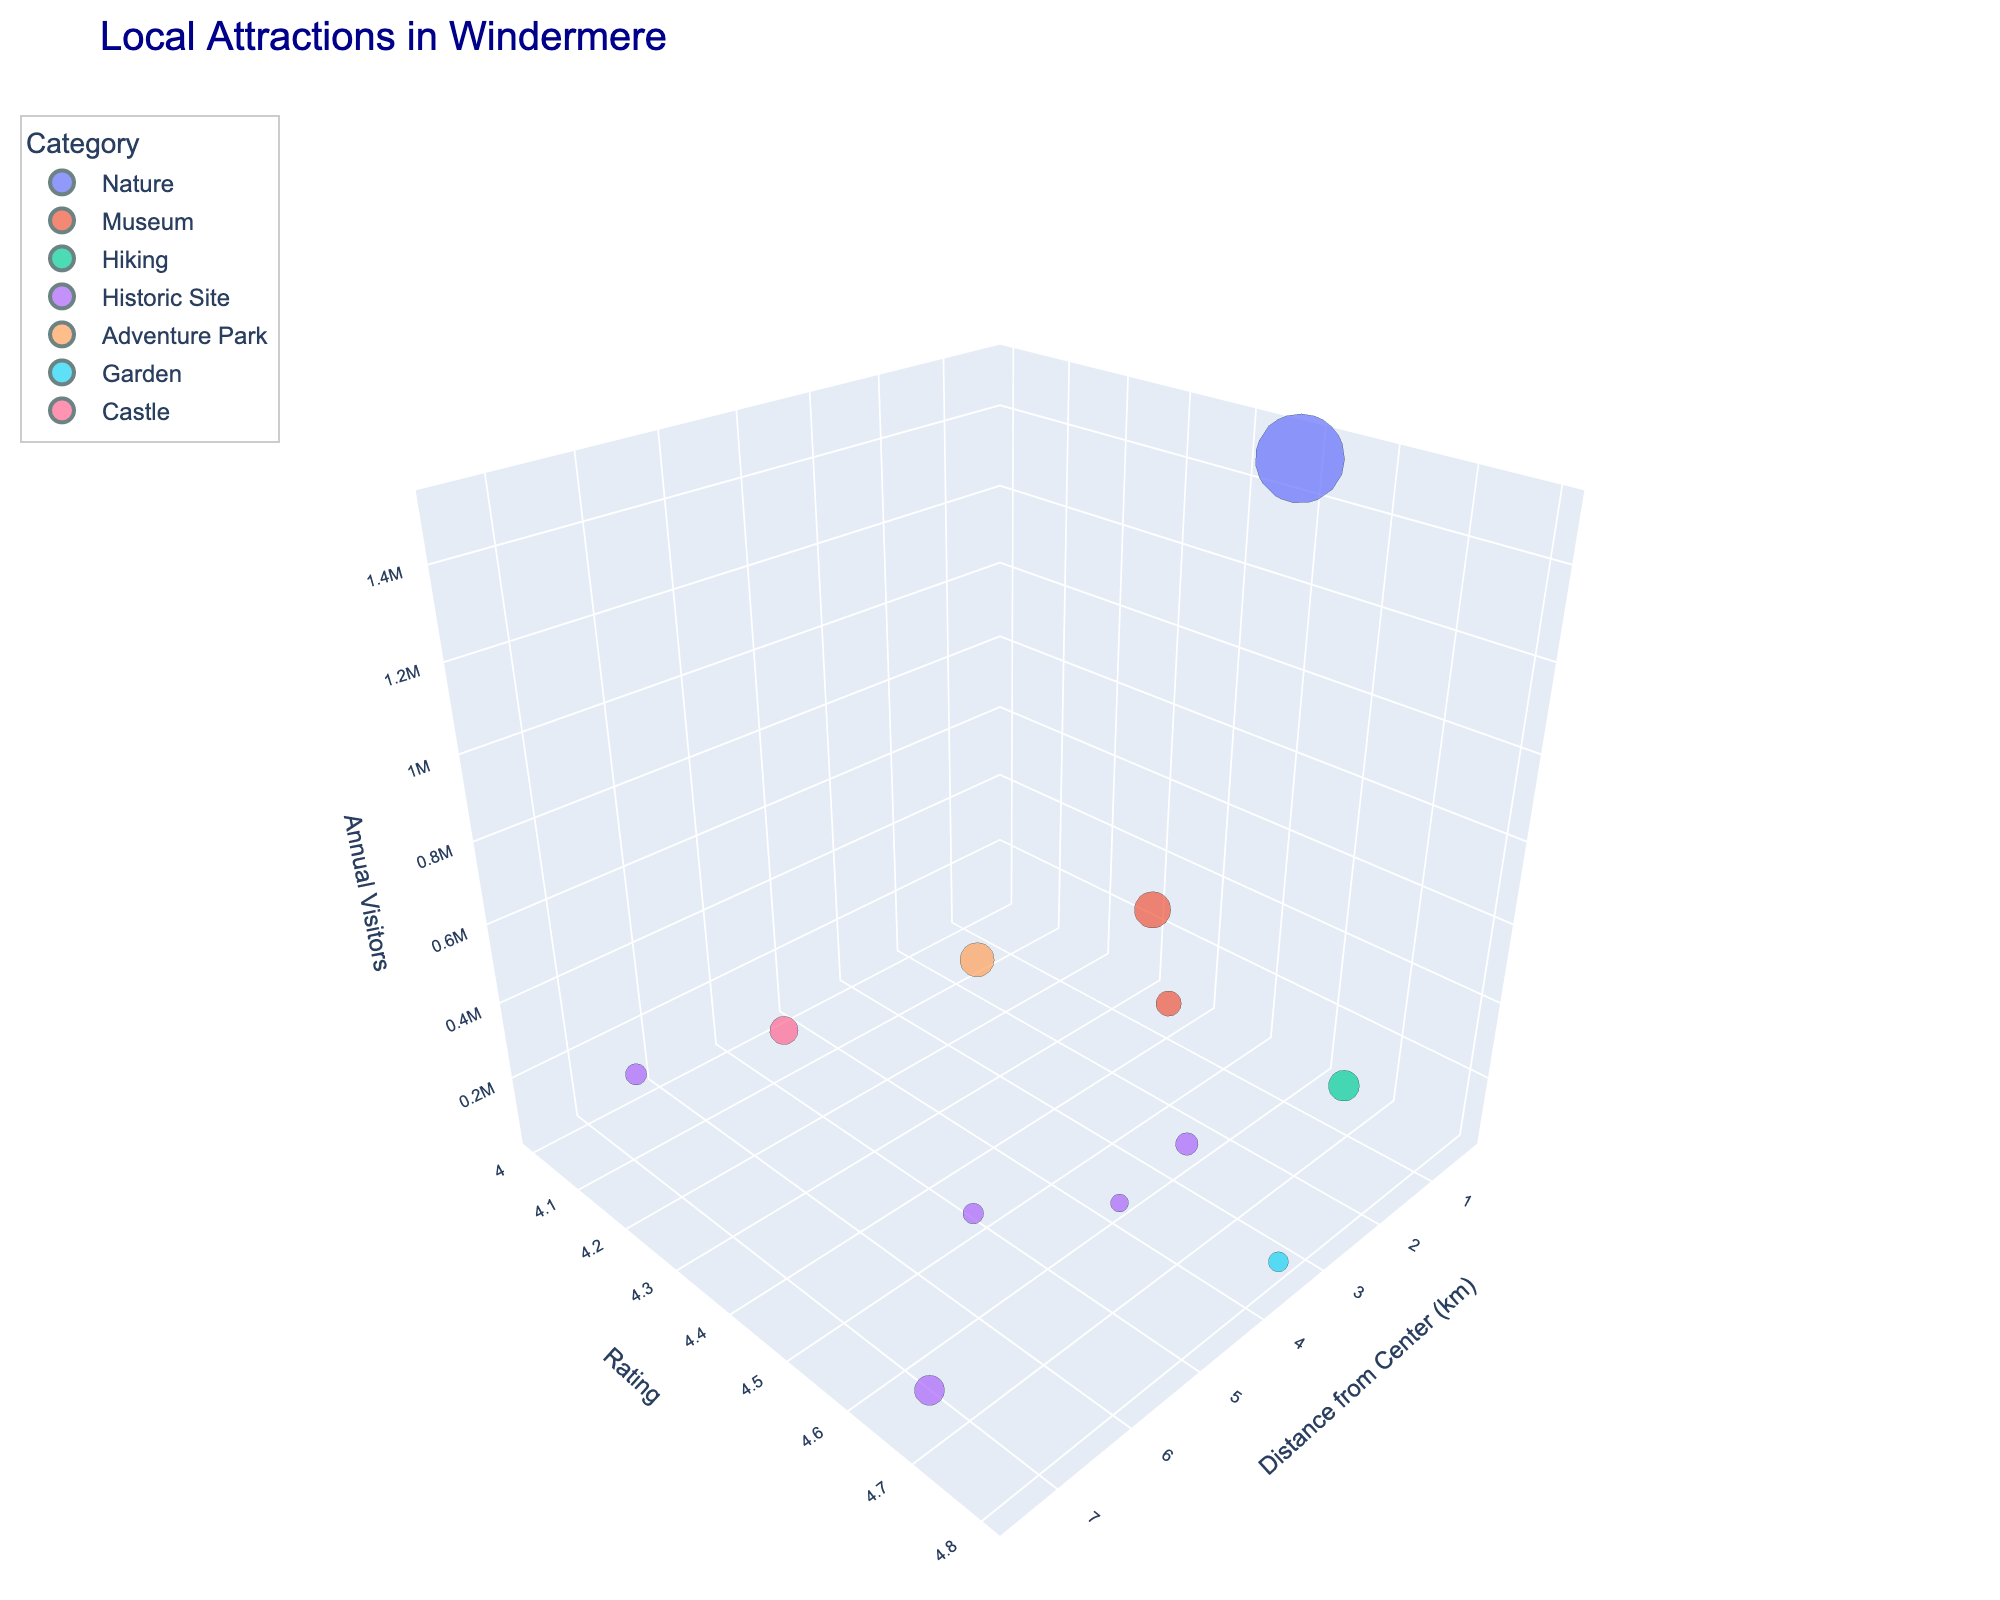What is the title of the chart? The title of the chart is typically located at the top of the figure. It provides a summary of what the figure represents.
Answer: Local Attractions in Windermere Which attraction has the highest rating? To determine this, identify the highest value on the Rating axis and locate the corresponding data point.
Answer: Holehird Gardens How many attractions are categorized as Historic Site? Count the number of data points that are colored the same and identified by the legend for the Historic Site category.
Answer: 5 Which category includes the attraction with the most annual visitors? Find the largest bubble (representing the highest number of visitors) and note its color. Then refer to the legend to identify the category.
Answer: Nature What is the distance from the town center to the World of Beatrix Potter attraction? Find the data point labeled as World of Beatrix Potter and read its position on the Distance from Center (km) axis.
Answer: 0.3 km Between the Windermere Jetty Museum and Wray Castle, which has a higher visitor rating? Locate both data points on the Rating axis and compare their values.
Answer: Windermere Jetty Museum What is the average rating of all attractions? Sum the ratings of all attractions and divide by the number of attractions. (4.5+4.3+4.7+4.6+4.2+4.4+4.8+4.5+4.1+4.6+4.0+4.7) / 12 = 53.4 / 12 = 4.45
Answer: 4.45 Which attraction is furthest from the town center? Identify the data point with the highest value on the Distance from Center (km) axis.
Answer: Hill Top (Beatrix Potter's House) Which attraction has the fewest annual visitors but a rating above 4.5? Find the smallest bubble size that meets the condition of having a rating above 4.5.
Answer: Holehird Gardens Which has more visitors, the Blackwell Arts & Crafts House or the Townend Historic House, and by how much? Compare the sizes of the bubbles representing both attractions. The difference is 95,000 - 60,000 = 35,000 visitors.
Answer: Blackwell Arts & Crafts House by 35,000 